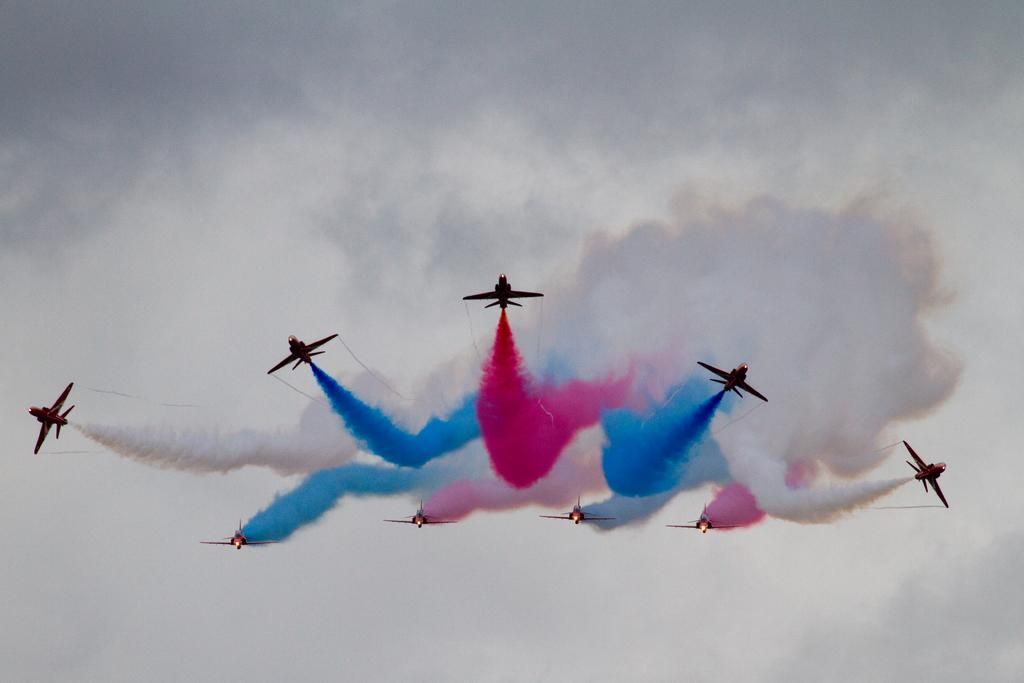What is the main subject of the image? The main subject of the image is aircrafts. What are the aircrafts doing in the image? The aircrafts are releasing color smoke in the image. What can be seen in the background of the image? There is sky visible in the background of the image. How many cherries are hanging from the aircrafts in the image? There are no cherries present in the image; the aircrafts are releasing color smoke. What stage of development are the aircrafts in the image? The provided facts do not give information about the stage of development of the aircrafts. 